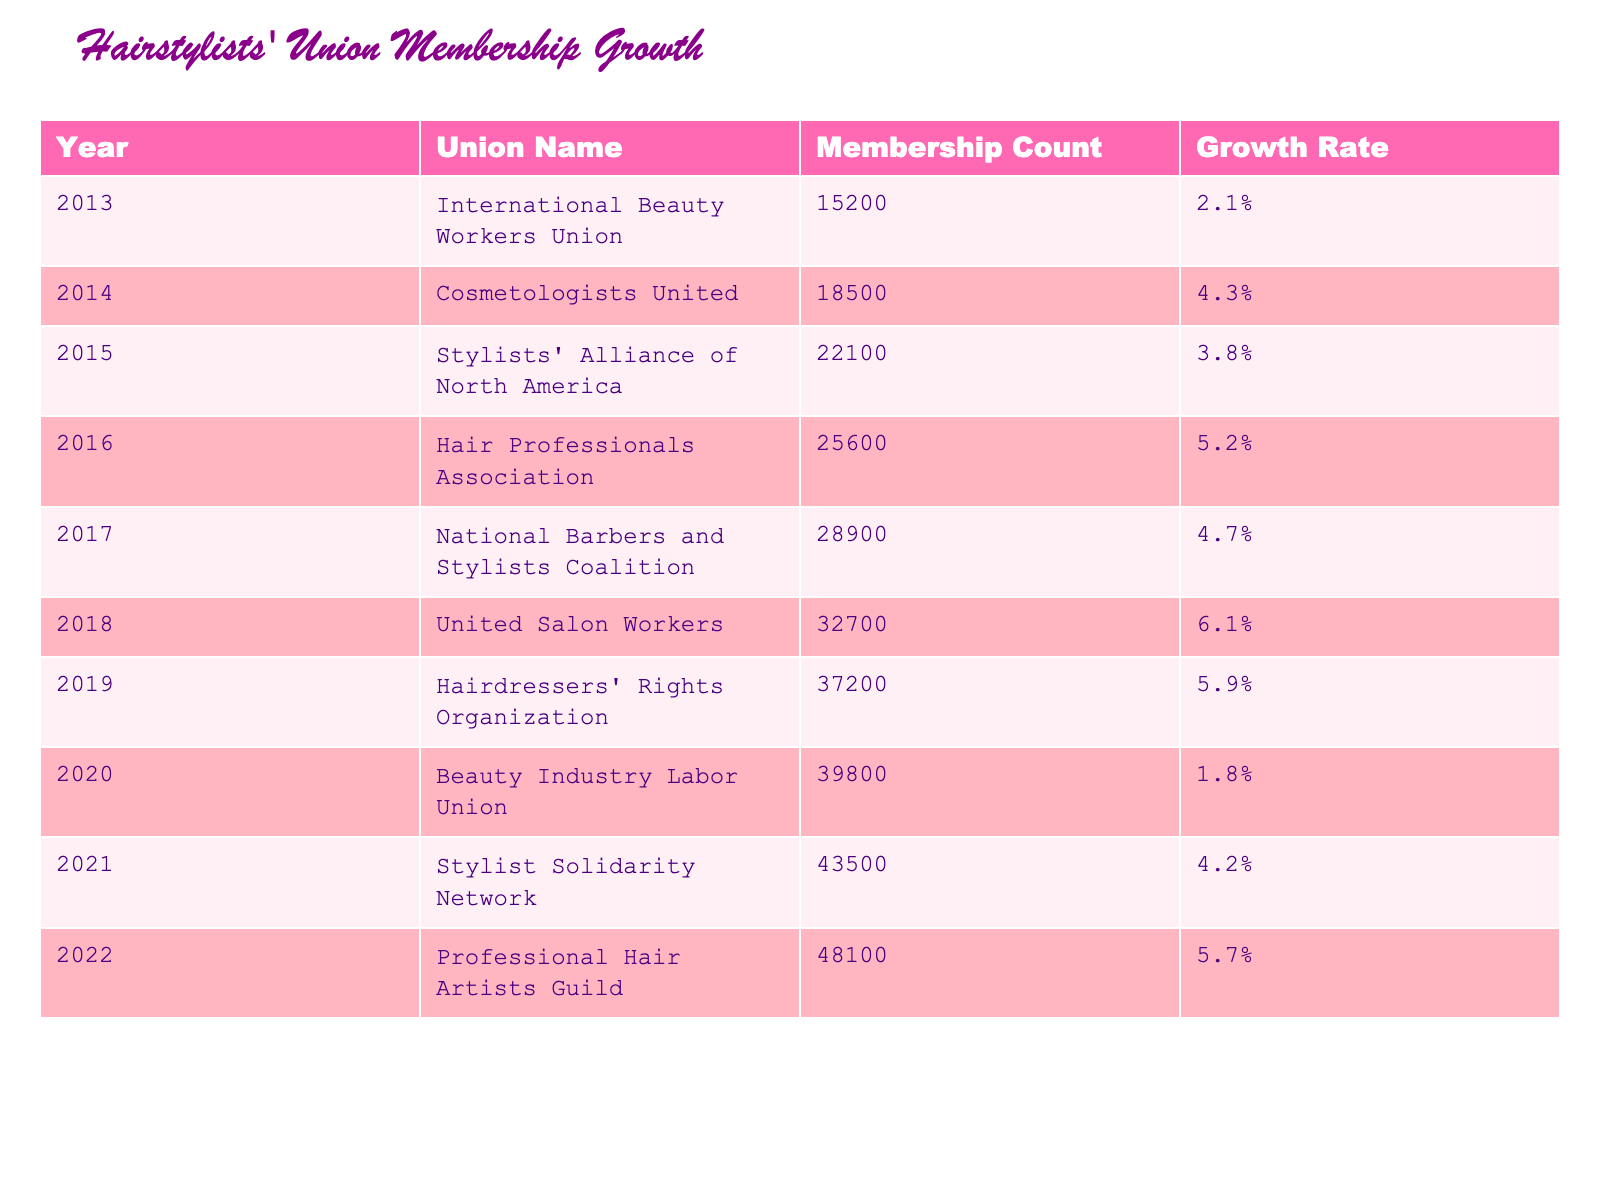What was the membership count of the International Beauty Workers Union in 2013? The table shows that the membership count for the International Beauty Workers Union in 2013 is listed directly under "Membership Count," which is 15200.
Answer: 15200 Which union had the highest membership growth rate? By reviewing the "Growth Rate" column, the highest rate is 6.1%, which corresponds to the United Salon Workers in 2018.
Answer: United Salon Workers What was the total membership count of all unions in 2022? Summing the membership counts from all unions listed in 2022 gives: 15200 + 18500 + 22100 + 25600 + 28900 + 32700 + 37200 + 39800 + 43500 + 48100 = 204100.
Answer: 204100 Did the Beauty Industry Labor Union see a growth rate above 2% in 2020? The table indicates that the growth rate for the Beauty Industry Labor Union in 2020 is 1.8%, which is below 2%, making the statement false.
Answer: No What was the average membership count for all unions from 2013 to 2022? The membership counts from 2013 to 2022 are: 15200, 18500, 22100, 25600, 28900, 32700, 37200, 39800, 43500, and 48100. Adding these gives a total of 204100, and dividing by the number of data points (10) results in an average of 204100/10 = 20410.
Answer: 20410 How much did the membership increase from 2019 to 2020? The membership count in 2019 is 37200 and in 2020 it is 39800. The increase can be calculated by subtracting the two values: 39800 - 37200 = 2600.
Answer: 2600 Which year had the lowest membership count? Looking through the membership counts for all the years, 2013 has the lowest value at 15200.
Answer: 2013 Was there a year when union membership growth rate was negative? All growth rates listed are positive percentages, indicating that there were no years with negative growth rates in the table.
Answer: No 